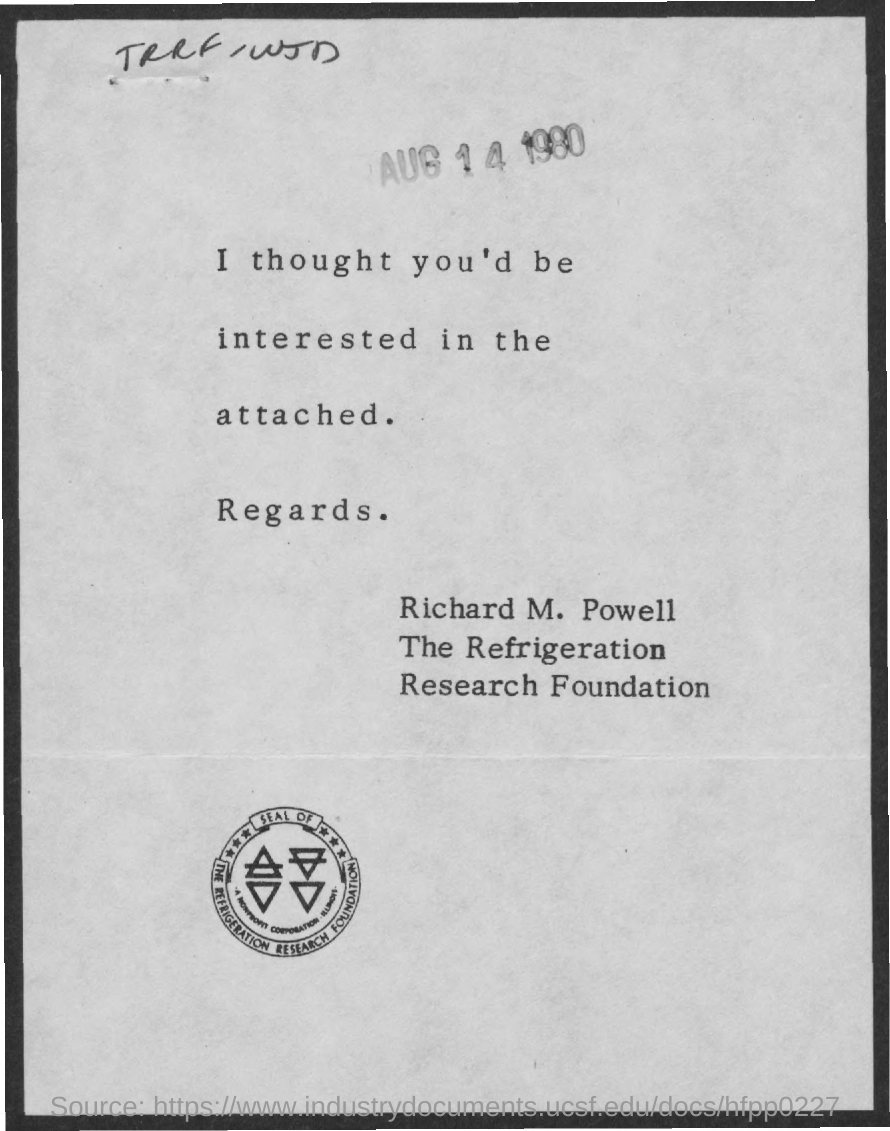List a handful of essential elements in this visual. The date mentioned is August 14, 1980. 